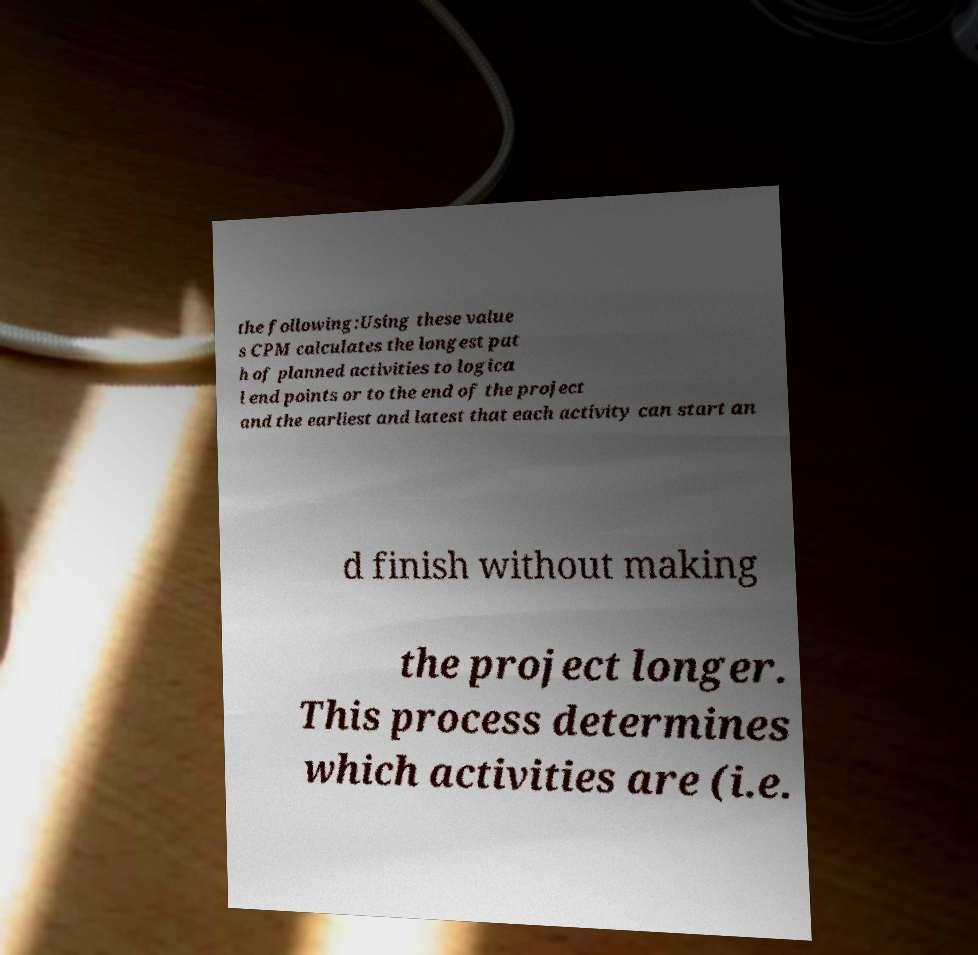What messages or text are displayed in this image? I need them in a readable, typed format. the following:Using these value s CPM calculates the longest pat h of planned activities to logica l end points or to the end of the project and the earliest and latest that each activity can start an d finish without making the project longer. This process determines which activities are (i.e. 